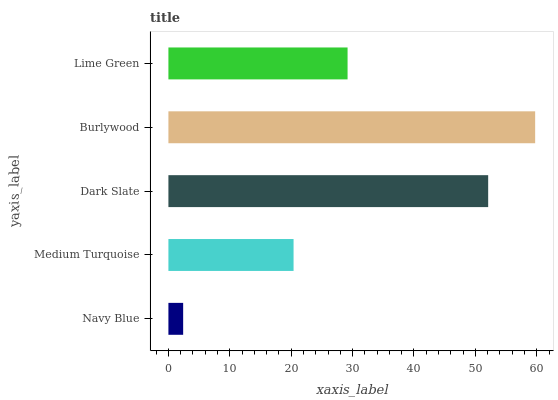Is Navy Blue the minimum?
Answer yes or no. Yes. Is Burlywood the maximum?
Answer yes or no. Yes. Is Medium Turquoise the minimum?
Answer yes or no. No. Is Medium Turquoise the maximum?
Answer yes or no. No. Is Medium Turquoise greater than Navy Blue?
Answer yes or no. Yes. Is Navy Blue less than Medium Turquoise?
Answer yes or no. Yes. Is Navy Blue greater than Medium Turquoise?
Answer yes or no. No. Is Medium Turquoise less than Navy Blue?
Answer yes or no. No. Is Lime Green the high median?
Answer yes or no. Yes. Is Lime Green the low median?
Answer yes or no. Yes. Is Burlywood the high median?
Answer yes or no. No. Is Burlywood the low median?
Answer yes or no. No. 